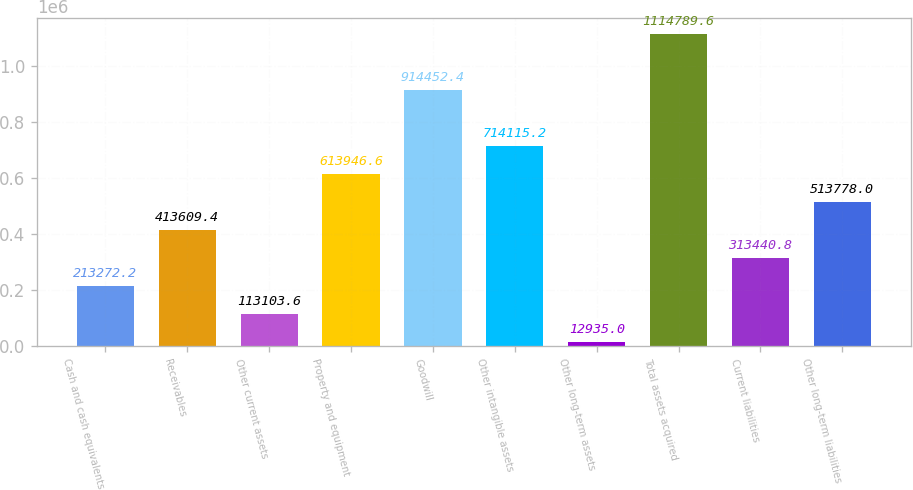<chart> <loc_0><loc_0><loc_500><loc_500><bar_chart><fcel>Cash and cash equivalents<fcel>Receivables<fcel>Other current assets<fcel>Property and equipment<fcel>Goodwill<fcel>Other intangible assets<fcel>Other long-term assets<fcel>Total assets acquired<fcel>Current liabilities<fcel>Other long-term liabilities<nl><fcel>213272<fcel>413609<fcel>113104<fcel>613947<fcel>914452<fcel>714115<fcel>12935<fcel>1.11479e+06<fcel>313441<fcel>513778<nl></chart> 